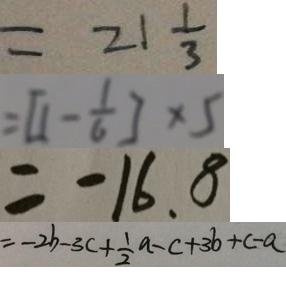Convert formula to latex. <formula><loc_0><loc_0><loc_500><loc_500>= 2 1 \frac { 1 } { 3 } 
 = [ 1 - \frac { 1 } { 6 } ] \times 5 
 = - 1 6 . 8 
 = - 2 b - 3 c + \frac { 1 } { 2 } a - c + 3 b + c - a</formula> 